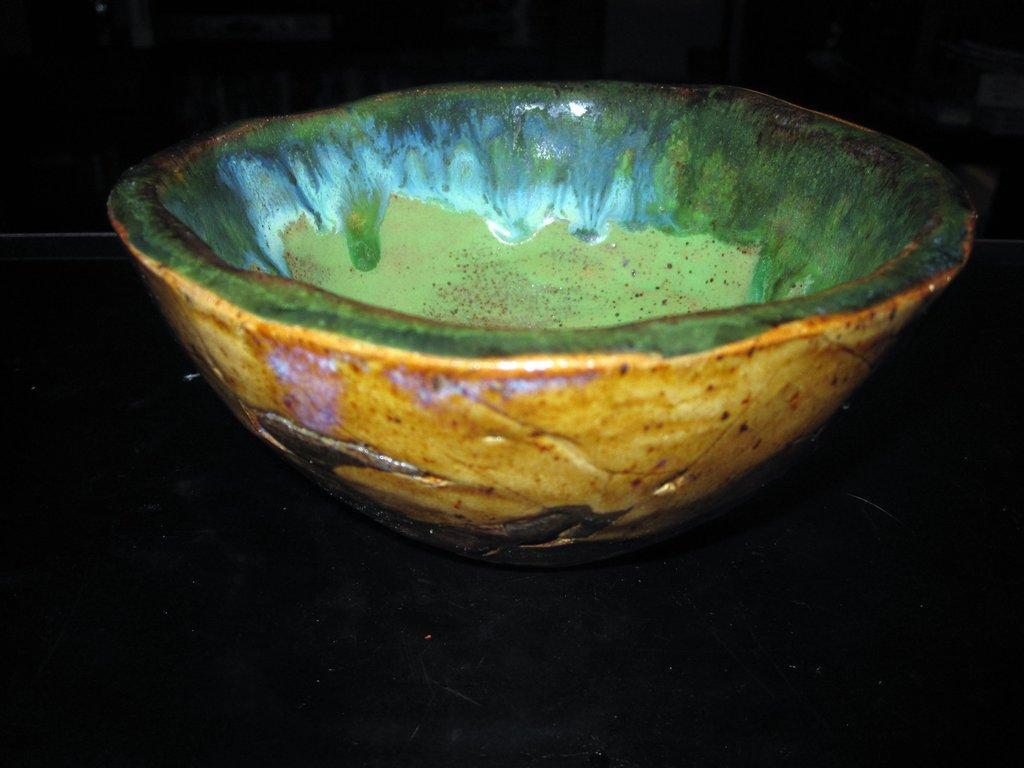Please provide a concise description of this image. In this image, we can see a bowl kept on the surface. 